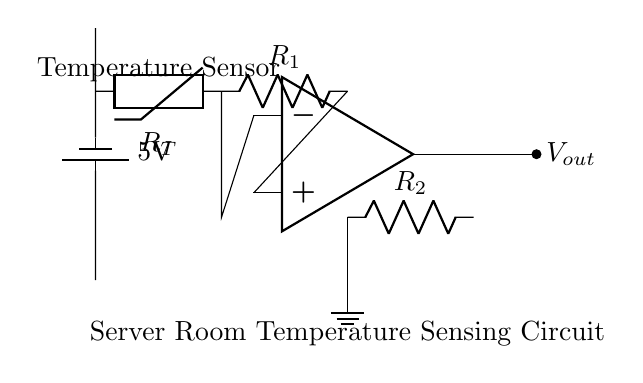What type of sensor is used in this circuit? The circuit uses a thermistor, which is indicated by the label "Temperature Sensor" in the diagram. A thermistor changes its resistance based on temperature, making it suitable for temperature sensing.
Answer: Thermistor What is the power supply voltage in the circuit? The power supply voltage is shown as 5V, which is labeled next to the battery in the circuit diagram. This indicates the potential provided for the operation of the components.
Answer: 5V How many resistors are present in the circuit? There are two resistors present in the circuit, represented as R1 and R2 in the diagram. These resistors are part of the voltage divider configuration.
Answer: Two What connection does the output voltage have? The output voltage, noted as Vout, is connected to the output terminal of the operational amplifier (op amp). This indicates that it outputs a voltage based on the input from the thermistor and resistors.
Answer: Output of op amp What is the function of the operational amplifier in this circuit? The operational amplifier amplifies the voltage difference between its two input terminals. In this circuit, it is used to amplify the voltage drop across the resistors, which corresponds to the temperature sensed by the thermistor.
Answer: Amplification What could happen if the resistance of the thermistor decreases? If the resistance of the thermistor decreases, the input to the operational amplifier would also change, resulting in a different output voltage. This would reflect an increase in temperature since thermistors typically have a negative temperature coefficient.
Answer: Output changes 